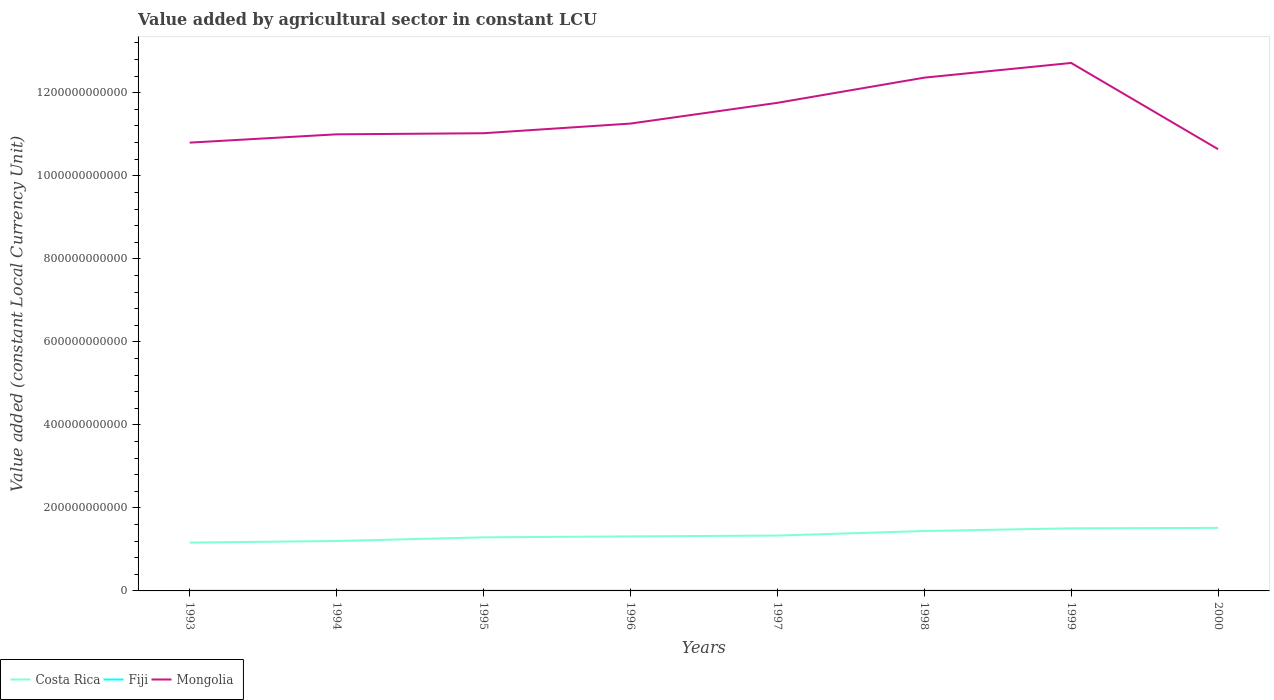Does the line corresponding to Fiji intersect with the line corresponding to Costa Rica?
Your response must be concise. No. Across all years, what is the maximum value added by agricultural sector in Mongolia?
Offer a terse response. 1.06e+12. What is the total value added by agricultural sector in Fiji in the graph?
Your answer should be compact. 6.77e+07. What is the difference between the highest and the second highest value added by agricultural sector in Costa Rica?
Your answer should be compact. 3.54e+1. What is the difference between the highest and the lowest value added by agricultural sector in Costa Rica?
Your answer should be very brief. 3. Is the value added by agricultural sector in Costa Rica strictly greater than the value added by agricultural sector in Mongolia over the years?
Keep it short and to the point. Yes. How many lines are there?
Your answer should be very brief. 3. How many years are there in the graph?
Make the answer very short. 8. What is the difference between two consecutive major ticks on the Y-axis?
Keep it short and to the point. 2.00e+11. Are the values on the major ticks of Y-axis written in scientific E-notation?
Offer a very short reply. No. Does the graph contain any zero values?
Keep it short and to the point. No. Where does the legend appear in the graph?
Give a very brief answer. Bottom left. How many legend labels are there?
Offer a very short reply. 3. What is the title of the graph?
Provide a succinct answer. Value added by agricultural sector in constant LCU. Does "Caribbean small states" appear as one of the legend labels in the graph?
Provide a succinct answer. No. What is the label or title of the Y-axis?
Make the answer very short. Value added (constant Local Currency Unit). What is the Value added (constant Local Currency Unit) of Costa Rica in 1993?
Provide a short and direct response. 1.16e+11. What is the Value added (constant Local Currency Unit) in Fiji in 1993?
Provide a short and direct response. 5.85e+08. What is the Value added (constant Local Currency Unit) of Mongolia in 1993?
Provide a succinct answer. 1.08e+12. What is the Value added (constant Local Currency Unit) of Costa Rica in 1994?
Offer a very short reply. 1.20e+11. What is the Value added (constant Local Currency Unit) of Fiji in 1994?
Offer a terse response. 6.49e+08. What is the Value added (constant Local Currency Unit) of Mongolia in 1994?
Your answer should be very brief. 1.10e+12. What is the Value added (constant Local Currency Unit) in Costa Rica in 1995?
Offer a terse response. 1.29e+11. What is the Value added (constant Local Currency Unit) in Fiji in 1995?
Offer a very short reply. 6.28e+08. What is the Value added (constant Local Currency Unit) of Mongolia in 1995?
Provide a short and direct response. 1.10e+12. What is the Value added (constant Local Currency Unit) in Costa Rica in 1996?
Ensure brevity in your answer.  1.31e+11. What is the Value added (constant Local Currency Unit) of Fiji in 1996?
Offer a terse response. 6.56e+08. What is the Value added (constant Local Currency Unit) in Mongolia in 1996?
Offer a terse response. 1.13e+12. What is the Value added (constant Local Currency Unit) of Costa Rica in 1997?
Offer a terse response. 1.33e+11. What is the Value added (constant Local Currency Unit) in Fiji in 1997?
Offer a very short reply. 5.88e+08. What is the Value added (constant Local Currency Unit) in Mongolia in 1997?
Provide a short and direct response. 1.18e+12. What is the Value added (constant Local Currency Unit) in Costa Rica in 1998?
Provide a short and direct response. 1.44e+11. What is the Value added (constant Local Currency Unit) of Fiji in 1998?
Offer a very short reply. 5.41e+08. What is the Value added (constant Local Currency Unit) in Mongolia in 1998?
Keep it short and to the point. 1.24e+12. What is the Value added (constant Local Currency Unit) of Costa Rica in 1999?
Ensure brevity in your answer.  1.51e+11. What is the Value added (constant Local Currency Unit) in Fiji in 1999?
Ensure brevity in your answer.  6.15e+08. What is the Value added (constant Local Currency Unit) of Mongolia in 1999?
Make the answer very short. 1.27e+12. What is the Value added (constant Local Currency Unit) of Costa Rica in 2000?
Offer a very short reply. 1.52e+11. What is the Value added (constant Local Currency Unit) in Fiji in 2000?
Your answer should be compact. 6.07e+08. What is the Value added (constant Local Currency Unit) of Mongolia in 2000?
Provide a succinct answer. 1.06e+12. Across all years, what is the maximum Value added (constant Local Currency Unit) of Costa Rica?
Your response must be concise. 1.52e+11. Across all years, what is the maximum Value added (constant Local Currency Unit) in Fiji?
Make the answer very short. 6.56e+08. Across all years, what is the maximum Value added (constant Local Currency Unit) of Mongolia?
Keep it short and to the point. 1.27e+12. Across all years, what is the minimum Value added (constant Local Currency Unit) of Costa Rica?
Offer a terse response. 1.16e+11. Across all years, what is the minimum Value added (constant Local Currency Unit) in Fiji?
Ensure brevity in your answer.  5.41e+08. Across all years, what is the minimum Value added (constant Local Currency Unit) of Mongolia?
Offer a terse response. 1.06e+12. What is the total Value added (constant Local Currency Unit) of Costa Rica in the graph?
Make the answer very short. 1.08e+12. What is the total Value added (constant Local Currency Unit) in Fiji in the graph?
Your answer should be compact. 4.87e+09. What is the total Value added (constant Local Currency Unit) of Mongolia in the graph?
Provide a succinct answer. 9.16e+12. What is the difference between the Value added (constant Local Currency Unit) of Costa Rica in 1993 and that in 1994?
Make the answer very short. -3.79e+09. What is the difference between the Value added (constant Local Currency Unit) of Fiji in 1993 and that in 1994?
Offer a terse response. -6.40e+07. What is the difference between the Value added (constant Local Currency Unit) in Mongolia in 1993 and that in 1994?
Keep it short and to the point. -2.00e+1. What is the difference between the Value added (constant Local Currency Unit) in Costa Rica in 1993 and that in 1995?
Keep it short and to the point. -1.26e+1. What is the difference between the Value added (constant Local Currency Unit) in Fiji in 1993 and that in 1995?
Provide a short and direct response. -4.33e+07. What is the difference between the Value added (constant Local Currency Unit) in Mongolia in 1993 and that in 1995?
Provide a succinct answer. -2.26e+1. What is the difference between the Value added (constant Local Currency Unit) in Costa Rica in 1993 and that in 1996?
Give a very brief answer. -1.49e+1. What is the difference between the Value added (constant Local Currency Unit) of Fiji in 1993 and that in 1996?
Provide a short and direct response. -7.12e+07. What is the difference between the Value added (constant Local Currency Unit) of Mongolia in 1993 and that in 1996?
Your response must be concise. -4.59e+1. What is the difference between the Value added (constant Local Currency Unit) of Costa Rica in 1993 and that in 1997?
Provide a short and direct response. -1.69e+1. What is the difference between the Value added (constant Local Currency Unit) of Fiji in 1993 and that in 1997?
Give a very brief answer. -3.55e+06. What is the difference between the Value added (constant Local Currency Unit) in Mongolia in 1993 and that in 1997?
Your answer should be compact. -9.59e+1. What is the difference between the Value added (constant Local Currency Unit) in Costa Rica in 1993 and that in 1998?
Keep it short and to the point. -2.78e+1. What is the difference between the Value added (constant Local Currency Unit) of Fiji in 1993 and that in 1998?
Make the answer very short. 4.33e+07. What is the difference between the Value added (constant Local Currency Unit) in Mongolia in 1993 and that in 1998?
Provide a succinct answer. -1.57e+11. What is the difference between the Value added (constant Local Currency Unit) of Costa Rica in 1993 and that in 1999?
Make the answer very short. -3.44e+1. What is the difference between the Value added (constant Local Currency Unit) in Fiji in 1993 and that in 1999?
Keep it short and to the point. -3.05e+07. What is the difference between the Value added (constant Local Currency Unit) of Mongolia in 1993 and that in 1999?
Make the answer very short. -1.92e+11. What is the difference between the Value added (constant Local Currency Unit) of Costa Rica in 1993 and that in 2000?
Your answer should be compact. -3.54e+1. What is the difference between the Value added (constant Local Currency Unit) in Fiji in 1993 and that in 2000?
Offer a very short reply. -2.27e+07. What is the difference between the Value added (constant Local Currency Unit) in Mongolia in 1993 and that in 2000?
Offer a terse response. 1.58e+1. What is the difference between the Value added (constant Local Currency Unit) of Costa Rica in 1994 and that in 1995?
Provide a succinct answer. -8.82e+09. What is the difference between the Value added (constant Local Currency Unit) in Fiji in 1994 and that in 1995?
Your answer should be compact. 2.08e+07. What is the difference between the Value added (constant Local Currency Unit) of Mongolia in 1994 and that in 1995?
Your answer should be very brief. -2.64e+09. What is the difference between the Value added (constant Local Currency Unit) of Costa Rica in 1994 and that in 1996?
Your answer should be compact. -1.12e+1. What is the difference between the Value added (constant Local Currency Unit) of Fiji in 1994 and that in 1996?
Your response must be concise. -7.20e+06. What is the difference between the Value added (constant Local Currency Unit) of Mongolia in 1994 and that in 1996?
Make the answer very short. -2.59e+1. What is the difference between the Value added (constant Local Currency Unit) in Costa Rica in 1994 and that in 1997?
Provide a succinct answer. -1.31e+1. What is the difference between the Value added (constant Local Currency Unit) of Fiji in 1994 and that in 1997?
Your answer should be compact. 6.05e+07. What is the difference between the Value added (constant Local Currency Unit) in Mongolia in 1994 and that in 1997?
Your response must be concise. -7.59e+1. What is the difference between the Value added (constant Local Currency Unit) in Costa Rica in 1994 and that in 1998?
Keep it short and to the point. -2.40e+1. What is the difference between the Value added (constant Local Currency Unit) in Fiji in 1994 and that in 1998?
Offer a very short reply. 1.07e+08. What is the difference between the Value added (constant Local Currency Unit) in Mongolia in 1994 and that in 1998?
Offer a terse response. -1.37e+11. What is the difference between the Value added (constant Local Currency Unit) of Costa Rica in 1994 and that in 1999?
Your response must be concise. -3.06e+1. What is the difference between the Value added (constant Local Currency Unit) in Fiji in 1994 and that in 1999?
Provide a succinct answer. 3.36e+07. What is the difference between the Value added (constant Local Currency Unit) in Mongolia in 1994 and that in 1999?
Ensure brevity in your answer.  -1.72e+11. What is the difference between the Value added (constant Local Currency Unit) of Costa Rica in 1994 and that in 2000?
Keep it short and to the point. -3.16e+1. What is the difference between the Value added (constant Local Currency Unit) in Fiji in 1994 and that in 2000?
Your answer should be compact. 4.13e+07. What is the difference between the Value added (constant Local Currency Unit) of Mongolia in 1994 and that in 2000?
Your response must be concise. 3.58e+1. What is the difference between the Value added (constant Local Currency Unit) in Costa Rica in 1995 and that in 1996?
Offer a terse response. -2.34e+09. What is the difference between the Value added (constant Local Currency Unit) of Fiji in 1995 and that in 1996?
Offer a very short reply. -2.80e+07. What is the difference between the Value added (constant Local Currency Unit) in Mongolia in 1995 and that in 1996?
Give a very brief answer. -2.33e+1. What is the difference between the Value added (constant Local Currency Unit) in Costa Rica in 1995 and that in 1997?
Your response must be concise. -4.29e+09. What is the difference between the Value added (constant Local Currency Unit) in Fiji in 1995 and that in 1997?
Your answer should be compact. 3.97e+07. What is the difference between the Value added (constant Local Currency Unit) in Mongolia in 1995 and that in 1997?
Make the answer very short. -7.32e+1. What is the difference between the Value added (constant Local Currency Unit) of Costa Rica in 1995 and that in 1998?
Keep it short and to the point. -1.52e+1. What is the difference between the Value added (constant Local Currency Unit) of Fiji in 1995 and that in 1998?
Ensure brevity in your answer.  8.65e+07. What is the difference between the Value added (constant Local Currency Unit) in Mongolia in 1995 and that in 1998?
Ensure brevity in your answer.  -1.34e+11. What is the difference between the Value added (constant Local Currency Unit) of Costa Rica in 1995 and that in 1999?
Offer a very short reply. -2.18e+1. What is the difference between the Value added (constant Local Currency Unit) of Fiji in 1995 and that in 1999?
Offer a very short reply. 1.28e+07. What is the difference between the Value added (constant Local Currency Unit) of Mongolia in 1995 and that in 1999?
Provide a short and direct response. -1.69e+11. What is the difference between the Value added (constant Local Currency Unit) in Costa Rica in 1995 and that in 2000?
Offer a terse response. -2.28e+1. What is the difference between the Value added (constant Local Currency Unit) of Fiji in 1995 and that in 2000?
Provide a succinct answer. 2.06e+07. What is the difference between the Value added (constant Local Currency Unit) of Mongolia in 1995 and that in 2000?
Your response must be concise. 3.84e+1. What is the difference between the Value added (constant Local Currency Unit) of Costa Rica in 1996 and that in 1997?
Offer a terse response. -1.95e+09. What is the difference between the Value added (constant Local Currency Unit) in Fiji in 1996 and that in 1997?
Make the answer very short. 6.77e+07. What is the difference between the Value added (constant Local Currency Unit) of Mongolia in 1996 and that in 1997?
Give a very brief answer. -4.99e+1. What is the difference between the Value added (constant Local Currency Unit) of Costa Rica in 1996 and that in 1998?
Give a very brief answer. -1.29e+1. What is the difference between the Value added (constant Local Currency Unit) of Fiji in 1996 and that in 1998?
Offer a terse response. 1.15e+08. What is the difference between the Value added (constant Local Currency Unit) in Mongolia in 1996 and that in 1998?
Your answer should be very brief. -1.11e+11. What is the difference between the Value added (constant Local Currency Unit) of Costa Rica in 1996 and that in 1999?
Provide a short and direct response. -1.94e+1. What is the difference between the Value added (constant Local Currency Unit) in Fiji in 1996 and that in 1999?
Your answer should be compact. 4.08e+07. What is the difference between the Value added (constant Local Currency Unit) of Mongolia in 1996 and that in 1999?
Provide a succinct answer. -1.46e+11. What is the difference between the Value added (constant Local Currency Unit) in Costa Rica in 1996 and that in 2000?
Offer a very short reply. -2.04e+1. What is the difference between the Value added (constant Local Currency Unit) of Fiji in 1996 and that in 2000?
Offer a terse response. 4.86e+07. What is the difference between the Value added (constant Local Currency Unit) of Mongolia in 1996 and that in 2000?
Give a very brief answer. 6.17e+1. What is the difference between the Value added (constant Local Currency Unit) in Costa Rica in 1997 and that in 1998?
Give a very brief answer. -1.09e+1. What is the difference between the Value added (constant Local Currency Unit) in Fiji in 1997 and that in 1998?
Provide a succinct answer. 4.68e+07. What is the difference between the Value added (constant Local Currency Unit) of Mongolia in 1997 and that in 1998?
Your response must be concise. -6.07e+1. What is the difference between the Value added (constant Local Currency Unit) of Costa Rica in 1997 and that in 1999?
Ensure brevity in your answer.  -1.75e+1. What is the difference between the Value added (constant Local Currency Unit) in Fiji in 1997 and that in 1999?
Make the answer very short. -2.69e+07. What is the difference between the Value added (constant Local Currency Unit) of Mongolia in 1997 and that in 1999?
Offer a very short reply. -9.61e+1. What is the difference between the Value added (constant Local Currency Unit) of Costa Rica in 1997 and that in 2000?
Provide a short and direct response. -1.85e+1. What is the difference between the Value added (constant Local Currency Unit) in Fiji in 1997 and that in 2000?
Provide a succinct answer. -1.91e+07. What is the difference between the Value added (constant Local Currency Unit) of Mongolia in 1997 and that in 2000?
Provide a succinct answer. 1.12e+11. What is the difference between the Value added (constant Local Currency Unit) in Costa Rica in 1998 and that in 1999?
Give a very brief answer. -6.53e+09. What is the difference between the Value added (constant Local Currency Unit) in Fiji in 1998 and that in 1999?
Offer a very short reply. -7.37e+07. What is the difference between the Value added (constant Local Currency Unit) in Mongolia in 1998 and that in 1999?
Provide a succinct answer. -3.54e+1. What is the difference between the Value added (constant Local Currency Unit) of Costa Rica in 1998 and that in 2000?
Ensure brevity in your answer.  -7.56e+09. What is the difference between the Value added (constant Local Currency Unit) in Fiji in 1998 and that in 2000?
Provide a succinct answer. -6.60e+07. What is the difference between the Value added (constant Local Currency Unit) in Mongolia in 1998 and that in 2000?
Provide a succinct answer. 1.72e+11. What is the difference between the Value added (constant Local Currency Unit) of Costa Rica in 1999 and that in 2000?
Provide a short and direct response. -1.02e+09. What is the difference between the Value added (constant Local Currency Unit) in Fiji in 1999 and that in 2000?
Keep it short and to the point. 7.78e+06. What is the difference between the Value added (constant Local Currency Unit) of Mongolia in 1999 and that in 2000?
Give a very brief answer. 2.08e+11. What is the difference between the Value added (constant Local Currency Unit) in Costa Rica in 1993 and the Value added (constant Local Currency Unit) in Fiji in 1994?
Offer a terse response. 1.16e+11. What is the difference between the Value added (constant Local Currency Unit) in Costa Rica in 1993 and the Value added (constant Local Currency Unit) in Mongolia in 1994?
Your answer should be compact. -9.83e+11. What is the difference between the Value added (constant Local Currency Unit) of Fiji in 1993 and the Value added (constant Local Currency Unit) of Mongolia in 1994?
Keep it short and to the point. -1.10e+12. What is the difference between the Value added (constant Local Currency Unit) in Costa Rica in 1993 and the Value added (constant Local Currency Unit) in Fiji in 1995?
Offer a terse response. 1.16e+11. What is the difference between the Value added (constant Local Currency Unit) in Costa Rica in 1993 and the Value added (constant Local Currency Unit) in Mongolia in 1995?
Your answer should be very brief. -9.86e+11. What is the difference between the Value added (constant Local Currency Unit) in Fiji in 1993 and the Value added (constant Local Currency Unit) in Mongolia in 1995?
Keep it short and to the point. -1.10e+12. What is the difference between the Value added (constant Local Currency Unit) in Costa Rica in 1993 and the Value added (constant Local Currency Unit) in Fiji in 1996?
Your answer should be very brief. 1.16e+11. What is the difference between the Value added (constant Local Currency Unit) of Costa Rica in 1993 and the Value added (constant Local Currency Unit) of Mongolia in 1996?
Provide a short and direct response. -1.01e+12. What is the difference between the Value added (constant Local Currency Unit) of Fiji in 1993 and the Value added (constant Local Currency Unit) of Mongolia in 1996?
Make the answer very short. -1.13e+12. What is the difference between the Value added (constant Local Currency Unit) in Costa Rica in 1993 and the Value added (constant Local Currency Unit) in Fiji in 1997?
Give a very brief answer. 1.16e+11. What is the difference between the Value added (constant Local Currency Unit) in Costa Rica in 1993 and the Value added (constant Local Currency Unit) in Mongolia in 1997?
Your answer should be compact. -1.06e+12. What is the difference between the Value added (constant Local Currency Unit) in Fiji in 1993 and the Value added (constant Local Currency Unit) in Mongolia in 1997?
Your answer should be very brief. -1.18e+12. What is the difference between the Value added (constant Local Currency Unit) of Costa Rica in 1993 and the Value added (constant Local Currency Unit) of Fiji in 1998?
Keep it short and to the point. 1.16e+11. What is the difference between the Value added (constant Local Currency Unit) of Costa Rica in 1993 and the Value added (constant Local Currency Unit) of Mongolia in 1998?
Ensure brevity in your answer.  -1.12e+12. What is the difference between the Value added (constant Local Currency Unit) of Fiji in 1993 and the Value added (constant Local Currency Unit) of Mongolia in 1998?
Give a very brief answer. -1.24e+12. What is the difference between the Value added (constant Local Currency Unit) of Costa Rica in 1993 and the Value added (constant Local Currency Unit) of Fiji in 1999?
Your answer should be very brief. 1.16e+11. What is the difference between the Value added (constant Local Currency Unit) in Costa Rica in 1993 and the Value added (constant Local Currency Unit) in Mongolia in 1999?
Your answer should be very brief. -1.16e+12. What is the difference between the Value added (constant Local Currency Unit) in Fiji in 1993 and the Value added (constant Local Currency Unit) in Mongolia in 1999?
Keep it short and to the point. -1.27e+12. What is the difference between the Value added (constant Local Currency Unit) of Costa Rica in 1993 and the Value added (constant Local Currency Unit) of Fiji in 2000?
Ensure brevity in your answer.  1.16e+11. What is the difference between the Value added (constant Local Currency Unit) in Costa Rica in 1993 and the Value added (constant Local Currency Unit) in Mongolia in 2000?
Your answer should be very brief. -9.48e+11. What is the difference between the Value added (constant Local Currency Unit) in Fiji in 1993 and the Value added (constant Local Currency Unit) in Mongolia in 2000?
Give a very brief answer. -1.06e+12. What is the difference between the Value added (constant Local Currency Unit) of Costa Rica in 1994 and the Value added (constant Local Currency Unit) of Fiji in 1995?
Your answer should be very brief. 1.20e+11. What is the difference between the Value added (constant Local Currency Unit) in Costa Rica in 1994 and the Value added (constant Local Currency Unit) in Mongolia in 1995?
Ensure brevity in your answer.  -9.82e+11. What is the difference between the Value added (constant Local Currency Unit) of Fiji in 1994 and the Value added (constant Local Currency Unit) of Mongolia in 1995?
Provide a short and direct response. -1.10e+12. What is the difference between the Value added (constant Local Currency Unit) of Costa Rica in 1994 and the Value added (constant Local Currency Unit) of Fiji in 1996?
Provide a short and direct response. 1.20e+11. What is the difference between the Value added (constant Local Currency Unit) in Costa Rica in 1994 and the Value added (constant Local Currency Unit) in Mongolia in 1996?
Provide a succinct answer. -1.01e+12. What is the difference between the Value added (constant Local Currency Unit) in Fiji in 1994 and the Value added (constant Local Currency Unit) in Mongolia in 1996?
Your answer should be very brief. -1.13e+12. What is the difference between the Value added (constant Local Currency Unit) of Costa Rica in 1994 and the Value added (constant Local Currency Unit) of Fiji in 1997?
Your answer should be compact. 1.20e+11. What is the difference between the Value added (constant Local Currency Unit) in Costa Rica in 1994 and the Value added (constant Local Currency Unit) in Mongolia in 1997?
Make the answer very short. -1.06e+12. What is the difference between the Value added (constant Local Currency Unit) of Fiji in 1994 and the Value added (constant Local Currency Unit) of Mongolia in 1997?
Your response must be concise. -1.18e+12. What is the difference between the Value added (constant Local Currency Unit) in Costa Rica in 1994 and the Value added (constant Local Currency Unit) in Fiji in 1998?
Your answer should be very brief. 1.20e+11. What is the difference between the Value added (constant Local Currency Unit) in Costa Rica in 1994 and the Value added (constant Local Currency Unit) in Mongolia in 1998?
Make the answer very short. -1.12e+12. What is the difference between the Value added (constant Local Currency Unit) in Fiji in 1994 and the Value added (constant Local Currency Unit) in Mongolia in 1998?
Ensure brevity in your answer.  -1.24e+12. What is the difference between the Value added (constant Local Currency Unit) in Costa Rica in 1994 and the Value added (constant Local Currency Unit) in Fiji in 1999?
Provide a succinct answer. 1.20e+11. What is the difference between the Value added (constant Local Currency Unit) of Costa Rica in 1994 and the Value added (constant Local Currency Unit) of Mongolia in 1999?
Give a very brief answer. -1.15e+12. What is the difference between the Value added (constant Local Currency Unit) in Fiji in 1994 and the Value added (constant Local Currency Unit) in Mongolia in 1999?
Give a very brief answer. -1.27e+12. What is the difference between the Value added (constant Local Currency Unit) in Costa Rica in 1994 and the Value added (constant Local Currency Unit) in Fiji in 2000?
Ensure brevity in your answer.  1.20e+11. What is the difference between the Value added (constant Local Currency Unit) of Costa Rica in 1994 and the Value added (constant Local Currency Unit) of Mongolia in 2000?
Offer a terse response. -9.44e+11. What is the difference between the Value added (constant Local Currency Unit) in Fiji in 1994 and the Value added (constant Local Currency Unit) in Mongolia in 2000?
Provide a succinct answer. -1.06e+12. What is the difference between the Value added (constant Local Currency Unit) of Costa Rica in 1995 and the Value added (constant Local Currency Unit) of Fiji in 1996?
Your response must be concise. 1.28e+11. What is the difference between the Value added (constant Local Currency Unit) in Costa Rica in 1995 and the Value added (constant Local Currency Unit) in Mongolia in 1996?
Offer a terse response. -9.97e+11. What is the difference between the Value added (constant Local Currency Unit) in Fiji in 1995 and the Value added (constant Local Currency Unit) in Mongolia in 1996?
Ensure brevity in your answer.  -1.13e+12. What is the difference between the Value added (constant Local Currency Unit) of Costa Rica in 1995 and the Value added (constant Local Currency Unit) of Fiji in 1997?
Offer a terse response. 1.28e+11. What is the difference between the Value added (constant Local Currency Unit) in Costa Rica in 1995 and the Value added (constant Local Currency Unit) in Mongolia in 1997?
Your response must be concise. -1.05e+12. What is the difference between the Value added (constant Local Currency Unit) of Fiji in 1995 and the Value added (constant Local Currency Unit) of Mongolia in 1997?
Provide a short and direct response. -1.18e+12. What is the difference between the Value added (constant Local Currency Unit) in Costa Rica in 1995 and the Value added (constant Local Currency Unit) in Fiji in 1998?
Ensure brevity in your answer.  1.29e+11. What is the difference between the Value added (constant Local Currency Unit) of Costa Rica in 1995 and the Value added (constant Local Currency Unit) of Mongolia in 1998?
Give a very brief answer. -1.11e+12. What is the difference between the Value added (constant Local Currency Unit) in Fiji in 1995 and the Value added (constant Local Currency Unit) in Mongolia in 1998?
Provide a short and direct response. -1.24e+12. What is the difference between the Value added (constant Local Currency Unit) in Costa Rica in 1995 and the Value added (constant Local Currency Unit) in Fiji in 1999?
Provide a succinct answer. 1.28e+11. What is the difference between the Value added (constant Local Currency Unit) in Costa Rica in 1995 and the Value added (constant Local Currency Unit) in Mongolia in 1999?
Give a very brief answer. -1.14e+12. What is the difference between the Value added (constant Local Currency Unit) in Fiji in 1995 and the Value added (constant Local Currency Unit) in Mongolia in 1999?
Give a very brief answer. -1.27e+12. What is the difference between the Value added (constant Local Currency Unit) in Costa Rica in 1995 and the Value added (constant Local Currency Unit) in Fiji in 2000?
Offer a very short reply. 1.28e+11. What is the difference between the Value added (constant Local Currency Unit) of Costa Rica in 1995 and the Value added (constant Local Currency Unit) of Mongolia in 2000?
Give a very brief answer. -9.35e+11. What is the difference between the Value added (constant Local Currency Unit) in Fiji in 1995 and the Value added (constant Local Currency Unit) in Mongolia in 2000?
Offer a terse response. -1.06e+12. What is the difference between the Value added (constant Local Currency Unit) in Costa Rica in 1996 and the Value added (constant Local Currency Unit) in Fiji in 1997?
Provide a short and direct response. 1.31e+11. What is the difference between the Value added (constant Local Currency Unit) of Costa Rica in 1996 and the Value added (constant Local Currency Unit) of Mongolia in 1997?
Your answer should be compact. -1.04e+12. What is the difference between the Value added (constant Local Currency Unit) in Fiji in 1996 and the Value added (constant Local Currency Unit) in Mongolia in 1997?
Keep it short and to the point. -1.18e+12. What is the difference between the Value added (constant Local Currency Unit) in Costa Rica in 1996 and the Value added (constant Local Currency Unit) in Fiji in 1998?
Your answer should be very brief. 1.31e+11. What is the difference between the Value added (constant Local Currency Unit) of Costa Rica in 1996 and the Value added (constant Local Currency Unit) of Mongolia in 1998?
Provide a short and direct response. -1.11e+12. What is the difference between the Value added (constant Local Currency Unit) in Fiji in 1996 and the Value added (constant Local Currency Unit) in Mongolia in 1998?
Your answer should be compact. -1.24e+12. What is the difference between the Value added (constant Local Currency Unit) in Costa Rica in 1996 and the Value added (constant Local Currency Unit) in Fiji in 1999?
Your response must be concise. 1.31e+11. What is the difference between the Value added (constant Local Currency Unit) in Costa Rica in 1996 and the Value added (constant Local Currency Unit) in Mongolia in 1999?
Provide a succinct answer. -1.14e+12. What is the difference between the Value added (constant Local Currency Unit) in Fiji in 1996 and the Value added (constant Local Currency Unit) in Mongolia in 1999?
Give a very brief answer. -1.27e+12. What is the difference between the Value added (constant Local Currency Unit) in Costa Rica in 1996 and the Value added (constant Local Currency Unit) in Fiji in 2000?
Offer a terse response. 1.31e+11. What is the difference between the Value added (constant Local Currency Unit) in Costa Rica in 1996 and the Value added (constant Local Currency Unit) in Mongolia in 2000?
Make the answer very short. -9.33e+11. What is the difference between the Value added (constant Local Currency Unit) in Fiji in 1996 and the Value added (constant Local Currency Unit) in Mongolia in 2000?
Your answer should be compact. -1.06e+12. What is the difference between the Value added (constant Local Currency Unit) of Costa Rica in 1997 and the Value added (constant Local Currency Unit) of Fiji in 1998?
Offer a terse response. 1.33e+11. What is the difference between the Value added (constant Local Currency Unit) of Costa Rica in 1997 and the Value added (constant Local Currency Unit) of Mongolia in 1998?
Make the answer very short. -1.10e+12. What is the difference between the Value added (constant Local Currency Unit) in Fiji in 1997 and the Value added (constant Local Currency Unit) in Mongolia in 1998?
Give a very brief answer. -1.24e+12. What is the difference between the Value added (constant Local Currency Unit) of Costa Rica in 1997 and the Value added (constant Local Currency Unit) of Fiji in 1999?
Offer a terse response. 1.33e+11. What is the difference between the Value added (constant Local Currency Unit) of Costa Rica in 1997 and the Value added (constant Local Currency Unit) of Mongolia in 1999?
Keep it short and to the point. -1.14e+12. What is the difference between the Value added (constant Local Currency Unit) of Fiji in 1997 and the Value added (constant Local Currency Unit) of Mongolia in 1999?
Provide a succinct answer. -1.27e+12. What is the difference between the Value added (constant Local Currency Unit) in Costa Rica in 1997 and the Value added (constant Local Currency Unit) in Fiji in 2000?
Your answer should be compact. 1.33e+11. What is the difference between the Value added (constant Local Currency Unit) of Costa Rica in 1997 and the Value added (constant Local Currency Unit) of Mongolia in 2000?
Provide a short and direct response. -9.31e+11. What is the difference between the Value added (constant Local Currency Unit) in Fiji in 1997 and the Value added (constant Local Currency Unit) in Mongolia in 2000?
Offer a very short reply. -1.06e+12. What is the difference between the Value added (constant Local Currency Unit) in Costa Rica in 1998 and the Value added (constant Local Currency Unit) in Fiji in 1999?
Provide a succinct answer. 1.44e+11. What is the difference between the Value added (constant Local Currency Unit) of Costa Rica in 1998 and the Value added (constant Local Currency Unit) of Mongolia in 1999?
Make the answer very short. -1.13e+12. What is the difference between the Value added (constant Local Currency Unit) of Fiji in 1998 and the Value added (constant Local Currency Unit) of Mongolia in 1999?
Your response must be concise. -1.27e+12. What is the difference between the Value added (constant Local Currency Unit) in Costa Rica in 1998 and the Value added (constant Local Currency Unit) in Fiji in 2000?
Offer a terse response. 1.44e+11. What is the difference between the Value added (constant Local Currency Unit) in Costa Rica in 1998 and the Value added (constant Local Currency Unit) in Mongolia in 2000?
Your answer should be compact. -9.20e+11. What is the difference between the Value added (constant Local Currency Unit) of Fiji in 1998 and the Value added (constant Local Currency Unit) of Mongolia in 2000?
Provide a short and direct response. -1.06e+12. What is the difference between the Value added (constant Local Currency Unit) of Costa Rica in 1999 and the Value added (constant Local Currency Unit) of Fiji in 2000?
Ensure brevity in your answer.  1.50e+11. What is the difference between the Value added (constant Local Currency Unit) of Costa Rica in 1999 and the Value added (constant Local Currency Unit) of Mongolia in 2000?
Your answer should be compact. -9.13e+11. What is the difference between the Value added (constant Local Currency Unit) of Fiji in 1999 and the Value added (constant Local Currency Unit) of Mongolia in 2000?
Provide a succinct answer. -1.06e+12. What is the average Value added (constant Local Currency Unit) of Costa Rica per year?
Make the answer very short. 1.35e+11. What is the average Value added (constant Local Currency Unit) in Fiji per year?
Provide a succinct answer. 6.09e+08. What is the average Value added (constant Local Currency Unit) in Mongolia per year?
Make the answer very short. 1.14e+12. In the year 1993, what is the difference between the Value added (constant Local Currency Unit) in Costa Rica and Value added (constant Local Currency Unit) in Fiji?
Give a very brief answer. 1.16e+11. In the year 1993, what is the difference between the Value added (constant Local Currency Unit) in Costa Rica and Value added (constant Local Currency Unit) in Mongolia?
Your response must be concise. -9.63e+11. In the year 1993, what is the difference between the Value added (constant Local Currency Unit) in Fiji and Value added (constant Local Currency Unit) in Mongolia?
Your response must be concise. -1.08e+12. In the year 1994, what is the difference between the Value added (constant Local Currency Unit) of Costa Rica and Value added (constant Local Currency Unit) of Fiji?
Provide a short and direct response. 1.20e+11. In the year 1994, what is the difference between the Value added (constant Local Currency Unit) in Costa Rica and Value added (constant Local Currency Unit) in Mongolia?
Provide a short and direct response. -9.80e+11. In the year 1994, what is the difference between the Value added (constant Local Currency Unit) in Fiji and Value added (constant Local Currency Unit) in Mongolia?
Your answer should be compact. -1.10e+12. In the year 1995, what is the difference between the Value added (constant Local Currency Unit) in Costa Rica and Value added (constant Local Currency Unit) in Fiji?
Give a very brief answer. 1.28e+11. In the year 1995, what is the difference between the Value added (constant Local Currency Unit) of Costa Rica and Value added (constant Local Currency Unit) of Mongolia?
Ensure brevity in your answer.  -9.73e+11. In the year 1995, what is the difference between the Value added (constant Local Currency Unit) in Fiji and Value added (constant Local Currency Unit) in Mongolia?
Offer a terse response. -1.10e+12. In the year 1996, what is the difference between the Value added (constant Local Currency Unit) in Costa Rica and Value added (constant Local Currency Unit) in Fiji?
Offer a terse response. 1.31e+11. In the year 1996, what is the difference between the Value added (constant Local Currency Unit) in Costa Rica and Value added (constant Local Currency Unit) in Mongolia?
Your answer should be very brief. -9.94e+11. In the year 1996, what is the difference between the Value added (constant Local Currency Unit) of Fiji and Value added (constant Local Currency Unit) of Mongolia?
Give a very brief answer. -1.13e+12. In the year 1997, what is the difference between the Value added (constant Local Currency Unit) in Costa Rica and Value added (constant Local Currency Unit) in Fiji?
Your answer should be compact. 1.33e+11. In the year 1997, what is the difference between the Value added (constant Local Currency Unit) of Costa Rica and Value added (constant Local Currency Unit) of Mongolia?
Ensure brevity in your answer.  -1.04e+12. In the year 1997, what is the difference between the Value added (constant Local Currency Unit) in Fiji and Value added (constant Local Currency Unit) in Mongolia?
Make the answer very short. -1.18e+12. In the year 1998, what is the difference between the Value added (constant Local Currency Unit) of Costa Rica and Value added (constant Local Currency Unit) of Fiji?
Provide a succinct answer. 1.44e+11. In the year 1998, what is the difference between the Value added (constant Local Currency Unit) of Costa Rica and Value added (constant Local Currency Unit) of Mongolia?
Provide a succinct answer. -1.09e+12. In the year 1998, what is the difference between the Value added (constant Local Currency Unit) of Fiji and Value added (constant Local Currency Unit) of Mongolia?
Give a very brief answer. -1.24e+12. In the year 1999, what is the difference between the Value added (constant Local Currency Unit) in Costa Rica and Value added (constant Local Currency Unit) in Fiji?
Keep it short and to the point. 1.50e+11. In the year 1999, what is the difference between the Value added (constant Local Currency Unit) in Costa Rica and Value added (constant Local Currency Unit) in Mongolia?
Give a very brief answer. -1.12e+12. In the year 1999, what is the difference between the Value added (constant Local Currency Unit) in Fiji and Value added (constant Local Currency Unit) in Mongolia?
Offer a very short reply. -1.27e+12. In the year 2000, what is the difference between the Value added (constant Local Currency Unit) in Costa Rica and Value added (constant Local Currency Unit) in Fiji?
Your answer should be compact. 1.51e+11. In the year 2000, what is the difference between the Value added (constant Local Currency Unit) in Costa Rica and Value added (constant Local Currency Unit) in Mongolia?
Provide a short and direct response. -9.12e+11. In the year 2000, what is the difference between the Value added (constant Local Currency Unit) of Fiji and Value added (constant Local Currency Unit) of Mongolia?
Provide a short and direct response. -1.06e+12. What is the ratio of the Value added (constant Local Currency Unit) of Costa Rica in 1993 to that in 1994?
Your answer should be compact. 0.97. What is the ratio of the Value added (constant Local Currency Unit) in Fiji in 1993 to that in 1994?
Offer a terse response. 0.9. What is the ratio of the Value added (constant Local Currency Unit) of Mongolia in 1993 to that in 1994?
Offer a terse response. 0.98. What is the ratio of the Value added (constant Local Currency Unit) of Costa Rica in 1993 to that in 1995?
Provide a succinct answer. 0.9. What is the ratio of the Value added (constant Local Currency Unit) in Fiji in 1993 to that in 1995?
Your response must be concise. 0.93. What is the ratio of the Value added (constant Local Currency Unit) of Mongolia in 1993 to that in 1995?
Your response must be concise. 0.98. What is the ratio of the Value added (constant Local Currency Unit) of Costa Rica in 1993 to that in 1996?
Keep it short and to the point. 0.89. What is the ratio of the Value added (constant Local Currency Unit) in Fiji in 1993 to that in 1996?
Ensure brevity in your answer.  0.89. What is the ratio of the Value added (constant Local Currency Unit) in Mongolia in 1993 to that in 1996?
Your response must be concise. 0.96. What is the ratio of the Value added (constant Local Currency Unit) in Costa Rica in 1993 to that in 1997?
Give a very brief answer. 0.87. What is the ratio of the Value added (constant Local Currency Unit) in Fiji in 1993 to that in 1997?
Your response must be concise. 0.99. What is the ratio of the Value added (constant Local Currency Unit) of Mongolia in 1993 to that in 1997?
Offer a very short reply. 0.92. What is the ratio of the Value added (constant Local Currency Unit) in Costa Rica in 1993 to that in 1998?
Your answer should be very brief. 0.81. What is the ratio of the Value added (constant Local Currency Unit) in Fiji in 1993 to that in 1998?
Your answer should be compact. 1.08. What is the ratio of the Value added (constant Local Currency Unit) in Mongolia in 1993 to that in 1998?
Your answer should be very brief. 0.87. What is the ratio of the Value added (constant Local Currency Unit) in Costa Rica in 1993 to that in 1999?
Ensure brevity in your answer.  0.77. What is the ratio of the Value added (constant Local Currency Unit) in Fiji in 1993 to that in 1999?
Keep it short and to the point. 0.95. What is the ratio of the Value added (constant Local Currency Unit) in Mongolia in 1993 to that in 1999?
Your answer should be compact. 0.85. What is the ratio of the Value added (constant Local Currency Unit) of Costa Rica in 1993 to that in 2000?
Offer a terse response. 0.77. What is the ratio of the Value added (constant Local Currency Unit) of Fiji in 1993 to that in 2000?
Your answer should be compact. 0.96. What is the ratio of the Value added (constant Local Currency Unit) in Mongolia in 1993 to that in 2000?
Provide a succinct answer. 1.01. What is the ratio of the Value added (constant Local Currency Unit) in Costa Rica in 1994 to that in 1995?
Provide a short and direct response. 0.93. What is the ratio of the Value added (constant Local Currency Unit) of Fiji in 1994 to that in 1995?
Keep it short and to the point. 1.03. What is the ratio of the Value added (constant Local Currency Unit) of Costa Rica in 1994 to that in 1996?
Your answer should be very brief. 0.92. What is the ratio of the Value added (constant Local Currency Unit) in Fiji in 1994 to that in 1996?
Your answer should be very brief. 0.99. What is the ratio of the Value added (constant Local Currency Unit) of Mongolia in 1994 to that in 1996?
Give a very brief answer. 0.98. What is the ratio of the Value added (constant Local Currency Unit) of Costa Rica in 1994 to that in 1997?
Offer a very short reply. 0.9. What is the ratio of the Value added (constant Local Currency Unit) of Fiji in 1994 to that in 1997?
Provide a succinct answer. 1.1. What is the ratio of the Value added (constant Local Currency Unit) of Mongolia in 1994 to that in 1997?
Your response must be concise. 0.94. What is the ratio of the Value added (constant Local Currency Unit) in Costa Rica in 1994 to that in 1998?
Make the answer very short. 0.83. What is the ratio of the Value added (constant Local Currency Unit) in Fiji in 1994 to that in 1998?
Ensure brevity in your answer.  1.2. What is the ratio of the Value added (constant Local Currency Unit) in Mongolia in 1994 to that in 1998?
Offer a terse response. 0.89. What is the ratio of the Value added (constant Local Currency Unit) of Costa Rica in 1994 to that in 1999?
Offer a very short reply. 0.8. What is the ratio of the Value added (constant Local Currency Unit) of Fiji in 1994 to that in 1999?
Offer a terse response. 1.05. What is the ratio of the Value added (constant Local Currency Unit) in Mongolia in 1994 to that in 1999?
Offer a very short reply. 0.86. What is the ratio of the Value added (constant Local Currency Unit) in Costa Rica in 1994 to that in 2000?
Give a very brief answer. 0.79. What is the ratio of the Value added (constant Local Currency Unit) in Fiji in 1994 to that in 2000?
Your response must be concise. 1.07. What is the ratio of the Value added (constant Local Currency Unit) of Mongolia in 1994 to that in 2000?
Give a very brief answer. 1.03. What is the ratio of the Value added (constant Local Currency Unit) in Costa Rica in 1995 to that in 1996?
Provide a succinct answer. 0.98. What is the ratio of the Value added (constant Local Currency Unit) in Fiji in 1995 to that in 1996?
Your answer should be very brief. 0.96. What is the ratio of the Value added (constant Local Currency Unit) of Mongolia in 1995 to that in 1996?
Your answer should be compact. 0.98. What is the ratio of the Value added (constant Local Currency Unit) of Costa Rica in 1995 to that in 1997?
Your answer should be very brief. 0.97. What is the ratio of the Value added (constant Local Currency Unit) of Fiji in 1995 to that in 1997?
Give a very brief answer. 1.07. What is the ratio of the Value added (constant Local Currency Unit) of Mongolia in 1995 to that in 1997?
Your answer should be compact. 0.94. What is the ratio of the Value added (constant Local Currency Unit) of Costa Rica in 1995 to that in 1998?
Ensure brevity in your answer.  0.89. What is the ratio of the Value added (constant Local Currency Unit) of Fiji in 1995 to that in 1998?
Keep it short and to the point. 1.16. What is the ratio of the Value added (constant Local Currency Unit) in Mongolia in 1995 to that in 1998?
Offer a terse response. 0.89. What is the ratio of the Value added (constant Local Currency Unit) in Costa Rica in 1995 to that in 1999?
Offer a terse response. 0.86. What is the ratio of the Value added (constant Local Currency Unit) in Fiji in 1995 to that in 1999?
Ensure brevity in your answer.  1.02. What is the ratio of the Value added (constant Local Currency Unit) in Mongolia in 1995 to that in 1999?
Offer a very short reply. 0.87. What is the ratio of the Value added (constant Local Currency Unit) of Costa Rica in 1995 to that in 2000?
Your response must be concise. 0.85. What is the ratio of the Value added (constant Local Currency Unit) of Fiji in 1995 to that in 2000?
Ensure brevity in your answer.  1.03. What is the ratio of the Value added (constant Local Currency Unit) in Mongolia in 1995 to that in 2000?
Your answer should be very brief. 1.04. What is the ratio of the Value added (constant Local Currency Unit) of Costa Rica in 1996 to that in 1997?
Offer a terse response. 0.99. What is the ratio of the Value added (constant Local Currency Unit) of Fiji in 1996 to that in 1997?
Offer a terse response. 1.12. What is the ratio of the Value added (constant Local Currency Unit) in Mongolia in 1996 to that in 1997?
Keep it short and to the point. 0.96. What is the ratio of the Value added (constant Local Currency Unit) in Costa Rica in 1996 to that in 1998?
Offer a very short reply. 0.91. What is the ratio of the Value added (constant Local Currency Unit) in Fiji in 1996 to that in 1998?
Offer a terse response. 1.21. What is the ratio of the Value added (constant Local Currency Unit) in Mongolia in 1996 to that in 1998?
Your answer should be compact. 0.91. What is the ratio of the Value added (constant Local Currency Unit) of Costa Rica in 1996 to that in 1999?
Ensure brevity in your answer.  0.87. What is the ratio of the Value added (constant Local Currency Unit) of Fiji in 1996 to that in 1999?
Your answer should be compact. 1.07. What is the ratio of the Value added (constant Local Currency Unit) of Mongolia in 1996 to that in 1999?
Make the answer very short. 0.89. What is the ratio of the Value added (constant Local Currency Unit) in Costa Rica in 1996 to that in 2000?
Provide a succinct answer. 0.87. What is the ratio of the Value added (constant Local Currency Unit) in Fiji in 1996 to that in 2000?
Offer a very short reply. 1.08. What is the ratio of the Value added (constant Local Currency Unit) in Mongolia in 1996 to that in 2000?
Provide a short and direct response. 1.06. What is the ratio of the Value added (constant Local Currency Unit) of Costa Rica in 1997 to that in 1998?
Make the answer very short. 0.92. What is the ratio of the Value added (constant Local Currency Unit) in Fiji in 1997 to that in 1998?
Your response must be concise. 1.09. What is the ratio of the Value added (constant Local Currency Unit) in Mongolia in 1997 to that in 1998?
Provide a succinct answer. 0.95. What is the ratio of the Value added (constant Local Currency Unit) of Costa Rica in 1997 to that in 1999?
Provide a short and direct response. 0.88. What is the ratio of the Value added (constant Local Currency Unit) in Fiji in 1997 to that in 1999?
Your answer should be very brief. 0.96. What is the ratio of the Value added (constant Local Currency Unit) of Mongolia in 1997 to that in 1999?
Provide a short and direct response. 0.92. What is the ratio of the Value added (constant Local Currency Unit) in Costa Rica in 1997 to that in 2000?
Ensure brevity in your answer.  0.88. What is the ratio of the Value added (constant Local Currency Unit) of Fiji in 1997 to that in 2000?
Your answer should be compact. 0.97. What is the ratio of the Value added (constant Local Currency Unit) in Mongolia in 1997 to that in 2000?
Provide a succinct answer. 1.1. What is the ratio of the Value added (constant Local Currency Unit) in Costa Rica in 1998 to that in 1999?
Your answer should be compact. 0.96. What is the ratio of the Value added (constant Local Currency Unit) in Fiji in 1998 to that in 1999?
Provide a succinct answer. 0.88. What is the ratio of the Value added (constant Local Currency Unit) of Mongolia in 1998 to that in 1999?
Keep it short and to the point. 0.97. What is the ratio of the Value added (constant Local Currency Unit) of Costa Rica in 1998 to that in 2000?
Keep it short and to the point. 0.95. What is the ratio of the Value added (constant Local Currency Unit) of Fiji in 1998 to that in 2000?
Offer a terse response. 0.89. What is the ratio of the Value added (constant Local Currency Unit) of Mongolia in 1998 to that in 2000?
Your answer should be very brief. 1.16. What is the ratio of the Value added (constant Local Currency Unit) of Costa Rica in 1999 to that in 2000?
Ensure brevity in your answer.  0.99. What is the ratio of the Value added (constant Local Currency Unit) of Fiji in 1999 to that in 2000?
Provide a succinct answer. 1.01. What is the ratio of the Value added (constant Local Currency Unit) in Mongolia in 1999 to that in 2000?
Keep it short and to the point. 1.2. What is the difference between the highest and the second highest Value added (constant Local Currency Unit) of Costa Rica?
Provide a succinct answer. 1.02e+09. What is the difference between the highest and the second highest Value added (constant Local Currency Unit) of Fiji?
Your answer should be very brief. 7.20e+06. What is the difference between the highest and the second highest Value added (constant Local Currency Unit) of Mongolia?
Your answer should be very brief. 3.54e+1. What is the difference between the highest and the lowest Value added (constant Local Currency Unit) of Costa Rica?
Ensure brevity in your answer.  3.54e+1. What is the difference between the highest and the lowest Value added (constant Local Currency Unit) in Fiji?
Your answer should be compact. 1.15e+08. What is the difference between the highest and the lowest Value added (constant Local Currency Unit) in Mongolia?
Provide a succinct answer. 2.08e+11. 